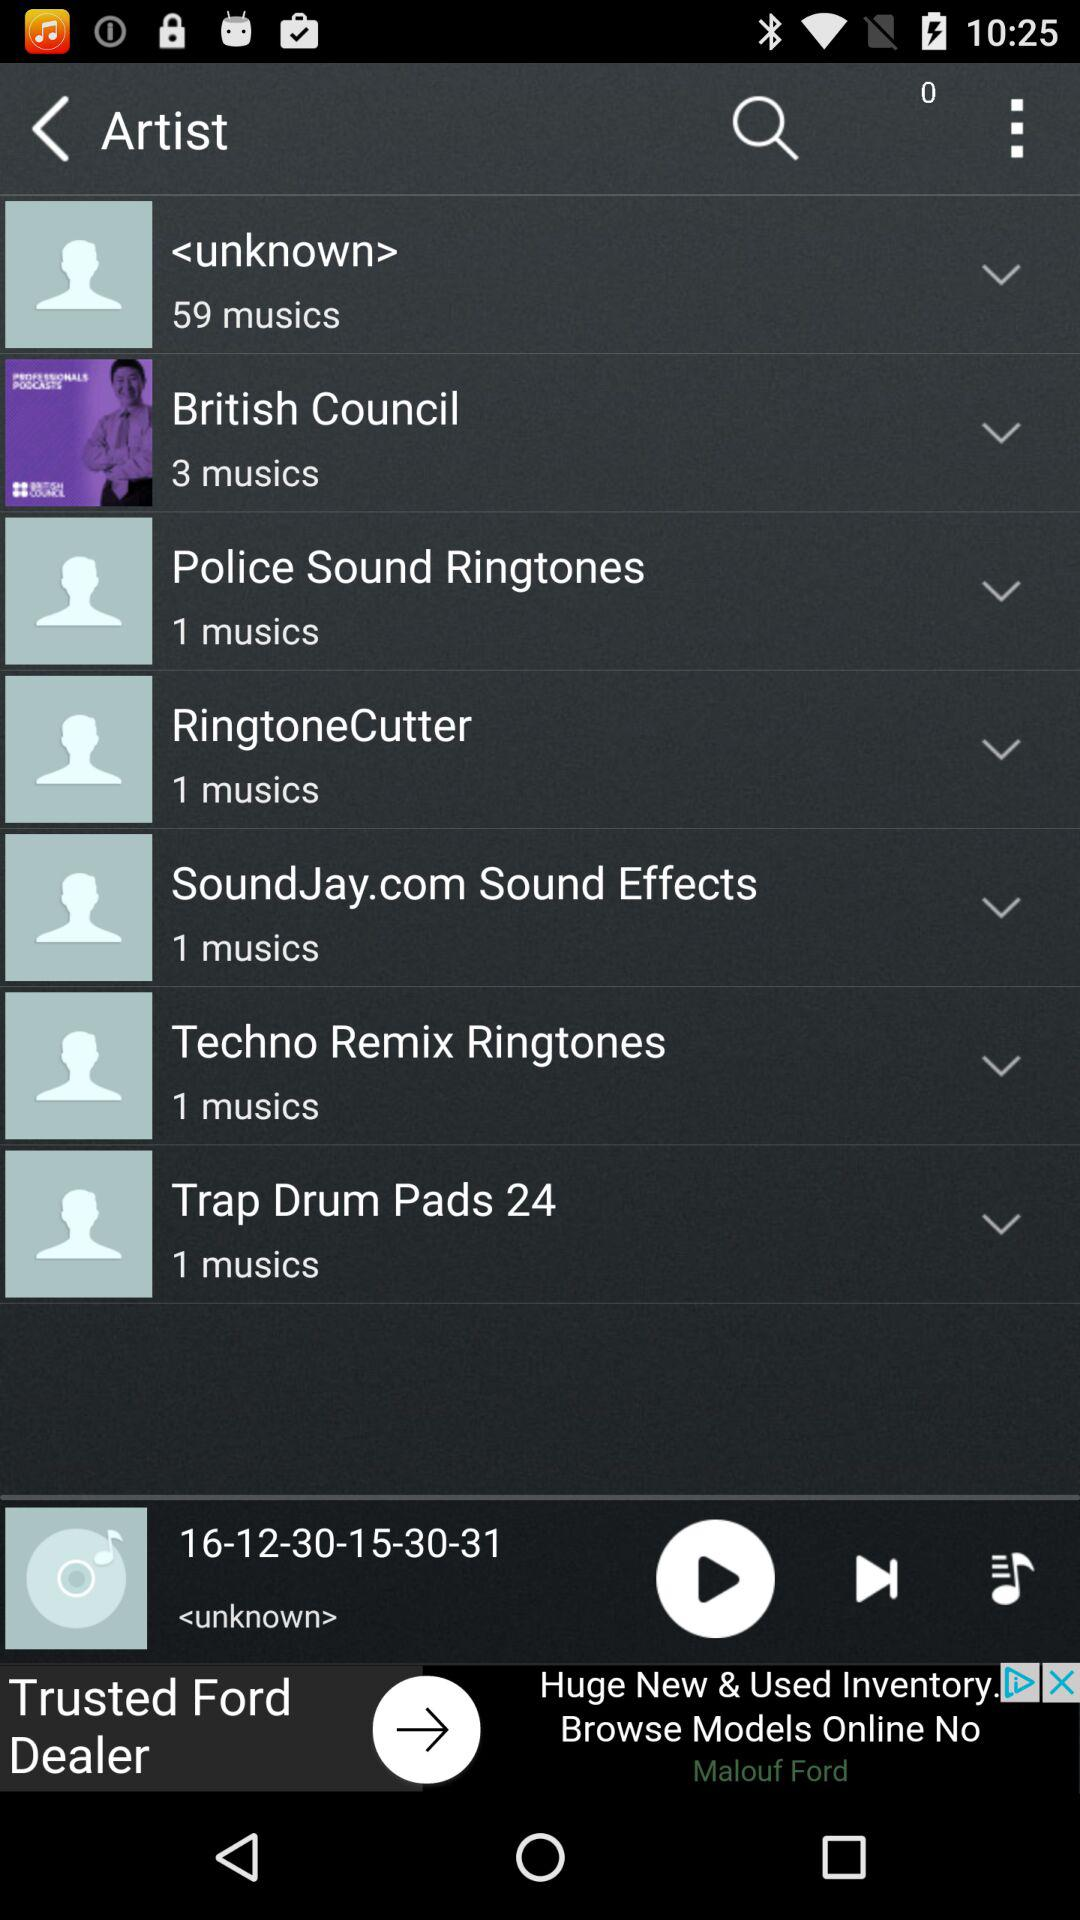Which track is currently playing? The currently playing track is "16-12-30-15-30-31". 